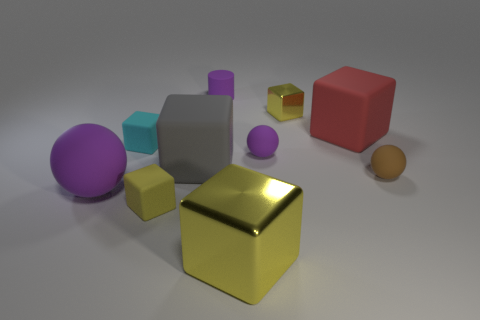Subtract all blue cylinders. How many yellow cubes are left? 3 Subtract 3 cubes. How many cubes are left? 3 Subtract all cyan blocks. How many blocks are left? 5 Subtract all small yellow shiny blocks. How many blocks are left? 5 Subtract all green cubes. Subtract all yellow spheres. How many cubes are left? 6 Subtract all balls. How many objects are left? 7 Add 7 small cyan things. How many small cyan things are left? 8 Add 3 big cyan shiny cylinders. How many big cyan shiny cylinders exist? 3 Subtract 0 purple cubes. How many objects are left? 10 Subtract all big yellow blocks. Subtract all yellow cubes. How many objects are left? 6 